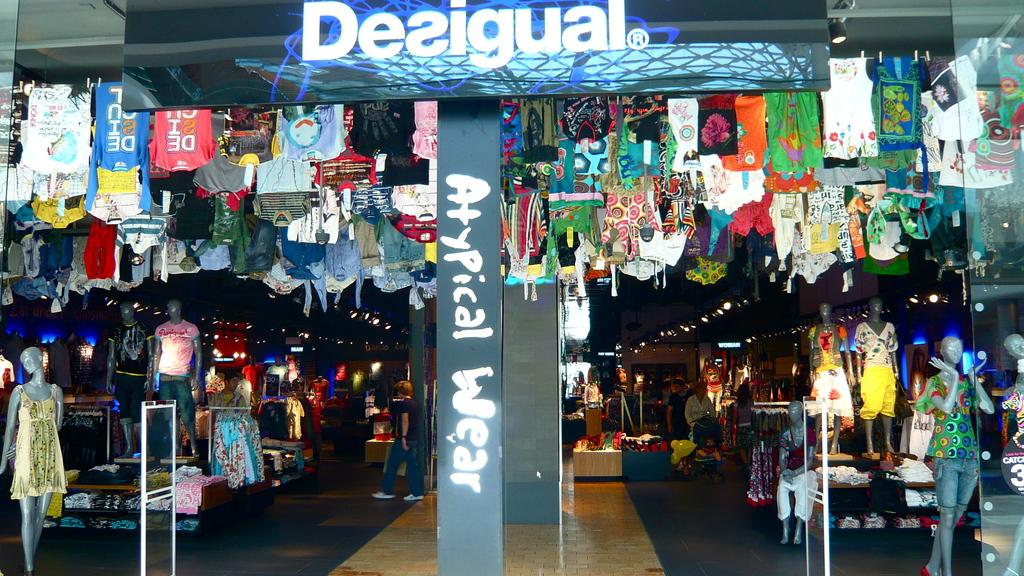What is hanging or displayed in the image? There is a banner in the image. What else can be seen in the image besides the banner? There are clothes and statues in the image. Is there any human activity depicted in the image? Yes, a person is walking in the image. What type of fuel is being used by the guitar in the image? There is no guitar present in the image, so the question about fuel is not applicable. 